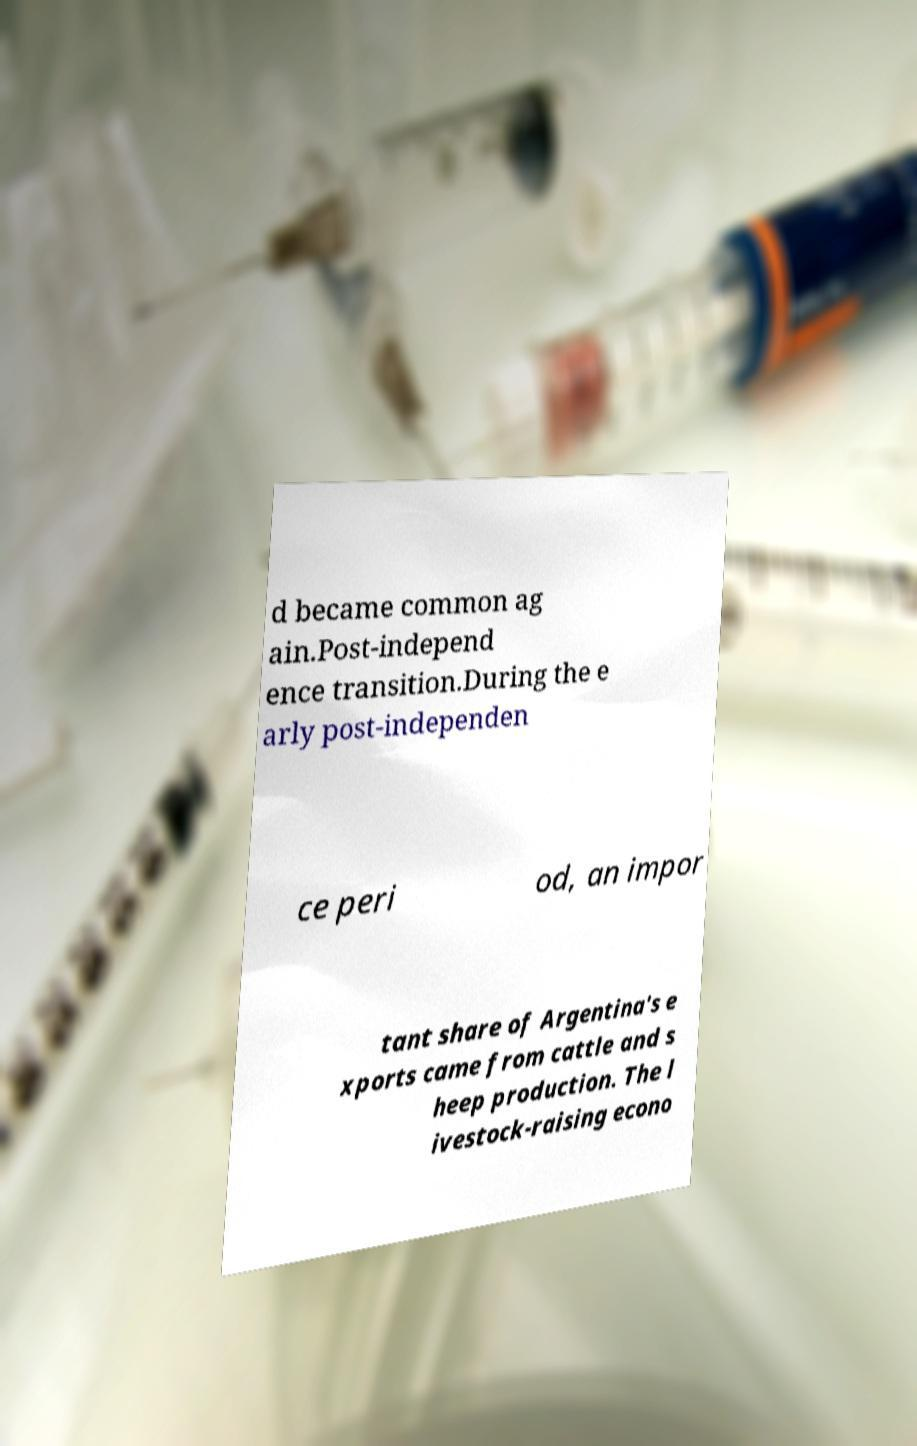Please identify and transcribe the text found in this image. d became common ag ain.Post-independ ence transition.During the e arly post-independen ce peri od, an impor tant share of Argentina's e xports came from cattle and s heep production. The l ivestock-raising econo 